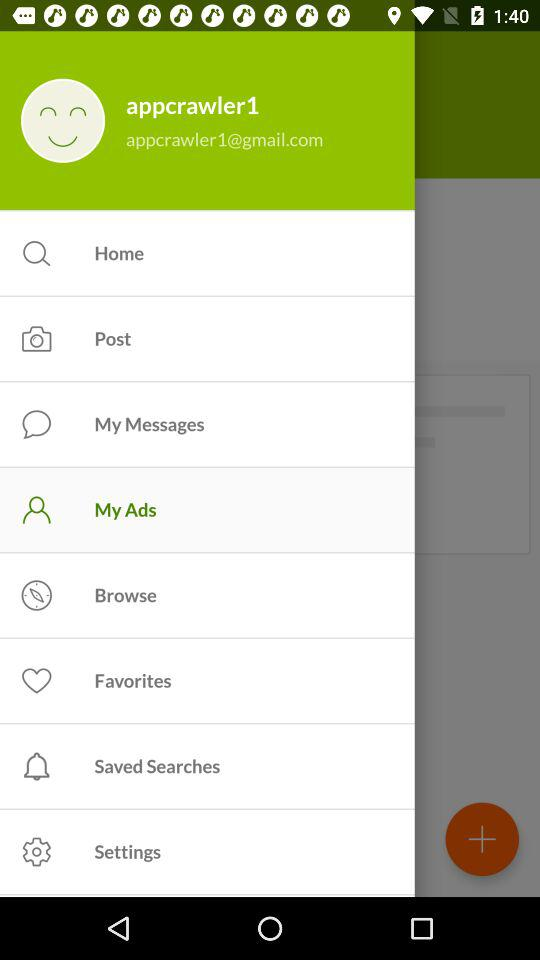What is the username? The username is "appcrawler1". 